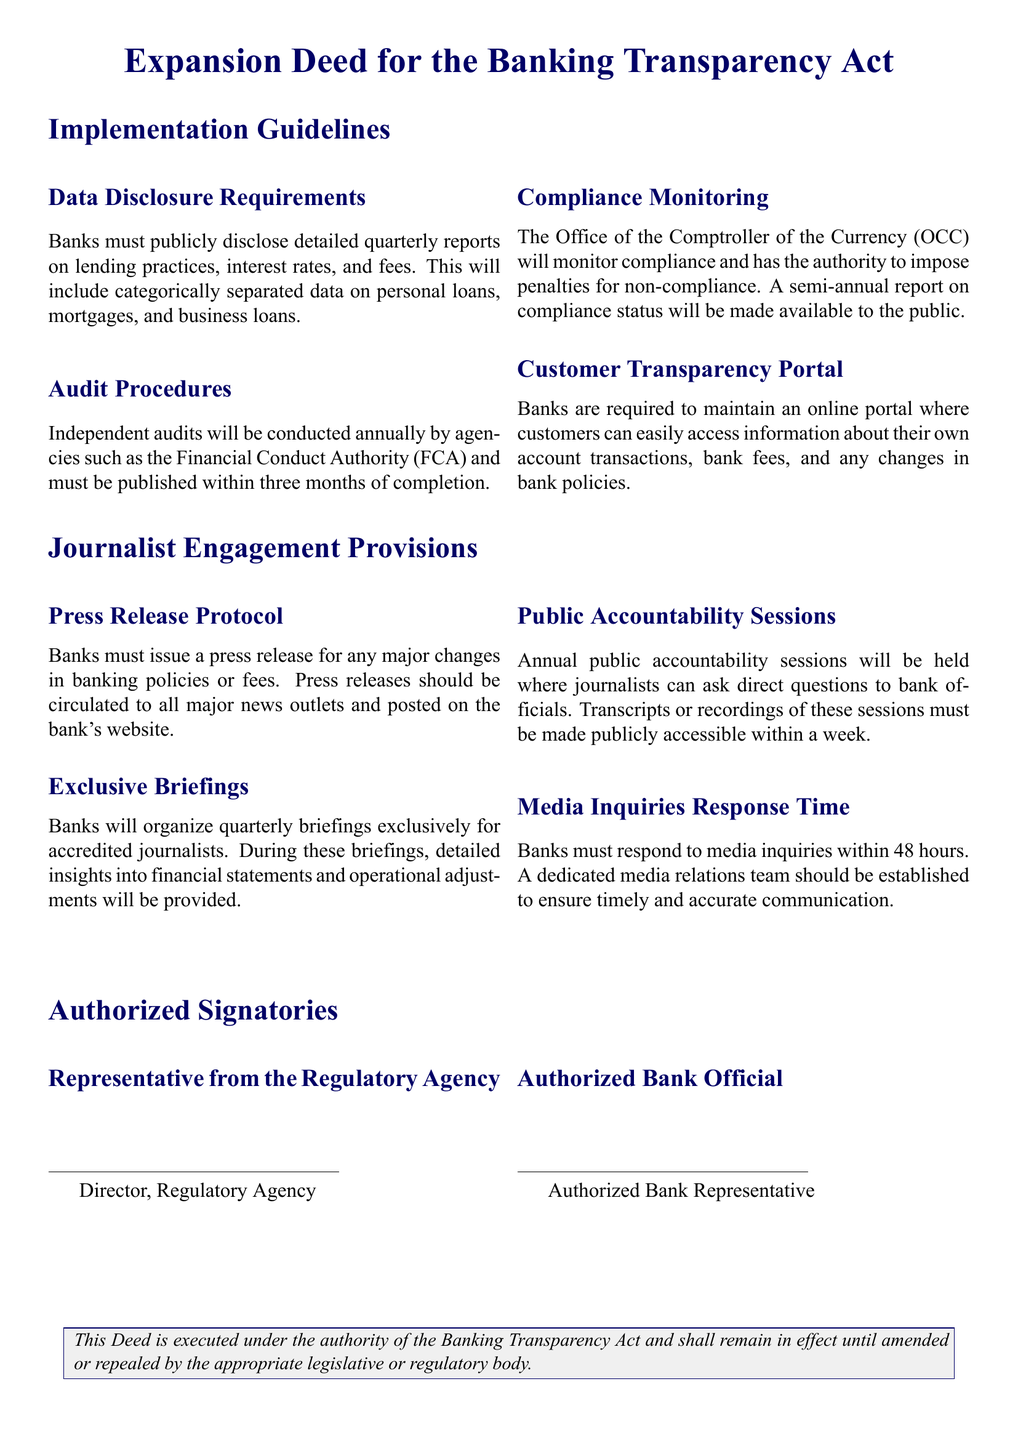What are the data disclosure requirements? The data disclosure requirements state that banks must publicly disclose detailed quarterly reports on lending practices, interest rates, and fees.
Answer: Detailed quarterly reports on lending practices, interest rates, and fees Who conducts independent audits? Independent audits are conducted by agencies such as the Financial Conduct Authority (FCA).
Answer: Financial Conduct Authority (FCA) How often are compliance monitoring reports made available to the public? Compliance monitoring reports are made available to the public semi-annually.
Answer: Semi-annually What is the response time for media inquiries? Banks must respond to media inquiries within a specific time frame outlined in the document.
Answer: 48 hours What type of sessions will be held annually for journalists? The document states that annual public accountability sessions will be held.
Answer: Public accountability sessions Who must issue a press release for major changes? The banks are responsible for issuing press releases for major changes in banking policies or fees.
Answer: Banks How many briefing sessions will be organized for accredited journalists? The document specifies that banks will organize quarterly briefings for journalists.
Answer: Quarterly What is the title of the authorized signatory from the regulatory agency? The title of the authorized signatory from the regulatory agency is mentioned in the document.
Answer: Director, Regulatory Agency 